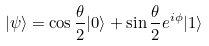Convert formula to latex. <formula><loc_0><loc_0><loc_500><loc_500>| \psi \rangle = \cos \frac { \theta } { 2 } | 0 \rangle + \sin \frac { \theta } { 2 } e ^ { i \phi } | 1 \rangle</formula> 